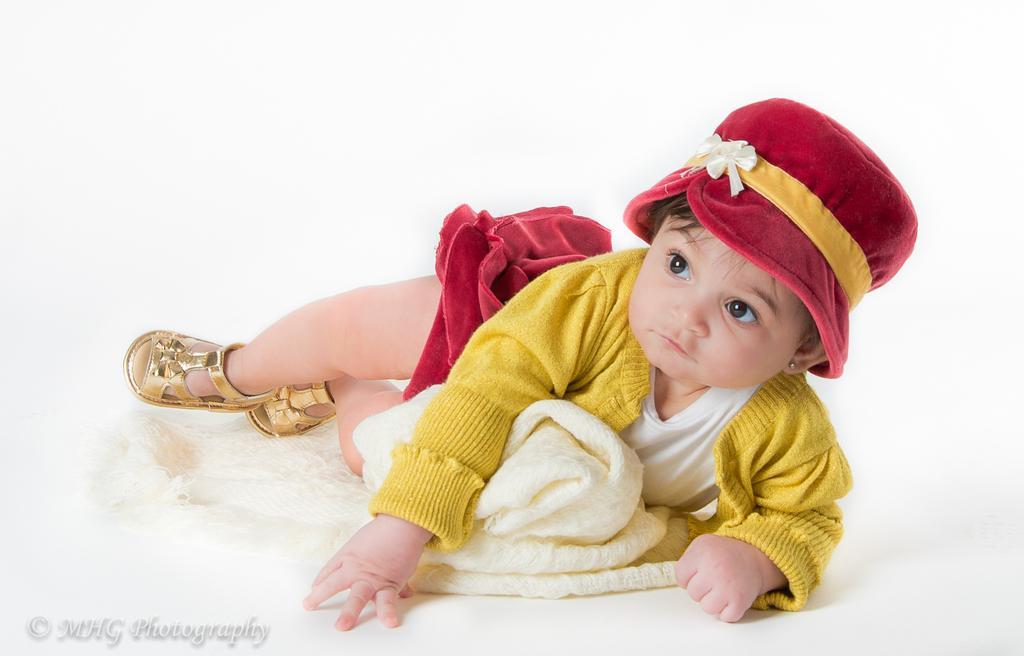Can you describe this image briefly? In this image, we can see a kid in the lying position, she is wearing a hat. 